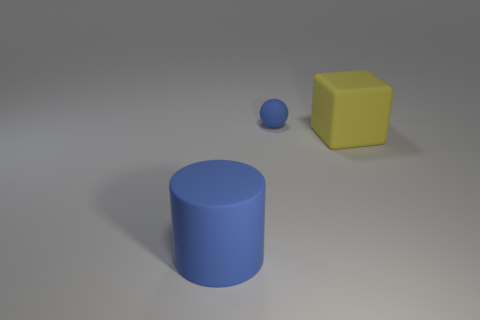Add 3 large yellow matte cubes. How many objects exist? 6 Subtract all cylinders. How many objects are left? 2 Subtract all shiny things. Subtract all large blue rubber things. How many objects are left? 2 Add 2 blue balls. How many blue balls are left? 3 Add 1 tiny blue objects. How many tiny blue objects exist? 2 Subtract 0 red balls. How many objects are left? 3 